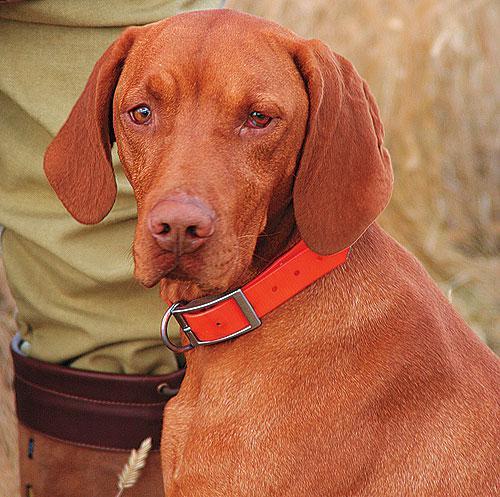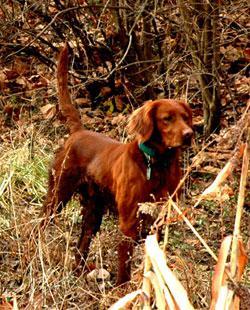The first image is the image on the left, the second image is the image on the right. Analyze the images presented: Is the assertion "Each image contains a single dog with floppy ears, and one image shows a dog outdoors in a non-reclining pose with its head and body angled rightward." valid? Answer yes or no. Yes. The first image is the image on the left, the second image is the image on the right. Evaluate the accuracy of this statement regarding the images: "The one dog in each image is wearing a collar.". Is it true? Answer yes or no. Yes. 